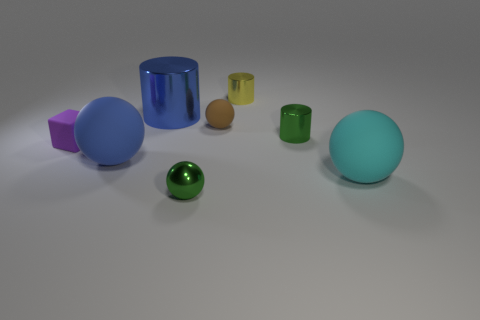Subtract all green metallic cylinders. How many cylinders are left? 2 Subtract 3 spheres. How many spheres are left? 1 Subtract all green cylinders. How many cylinders are left? 2 Subtract all yellow cubes. How many blue cylinders are left? 1 Add 2 small purple matte cubes. How many objects exist? 10 Subtract 1 brown spheres. How many objects are left? 7 Subtract all cylinders. How many objects are left? 5 Subtract all gray blocks. Subtract all cyan cylinders. How many blocks are left? 1 Subtract all metallic balls. Subtract all tiny green cylinders. How many objects are left? 6 Add 5 purple rubber blocks. How many purple rubber blocks are left? 6 